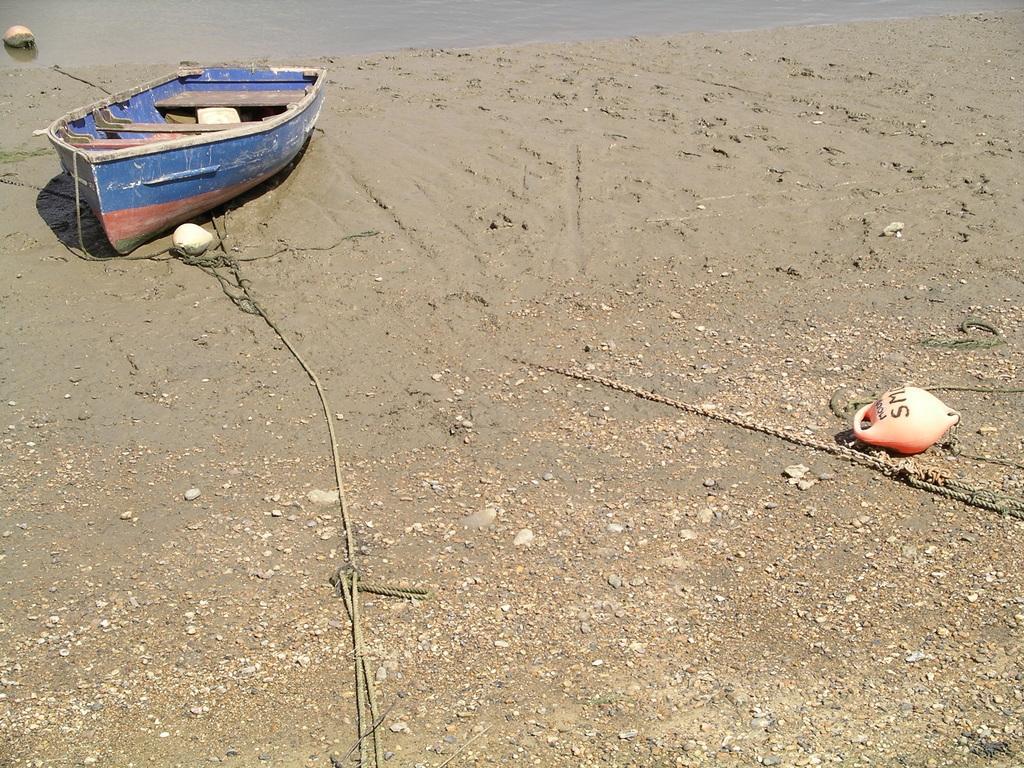Provide a one-sentence caption for the provided image. An orange buoy with the letters SM on it lies on the beach near a row boat. 